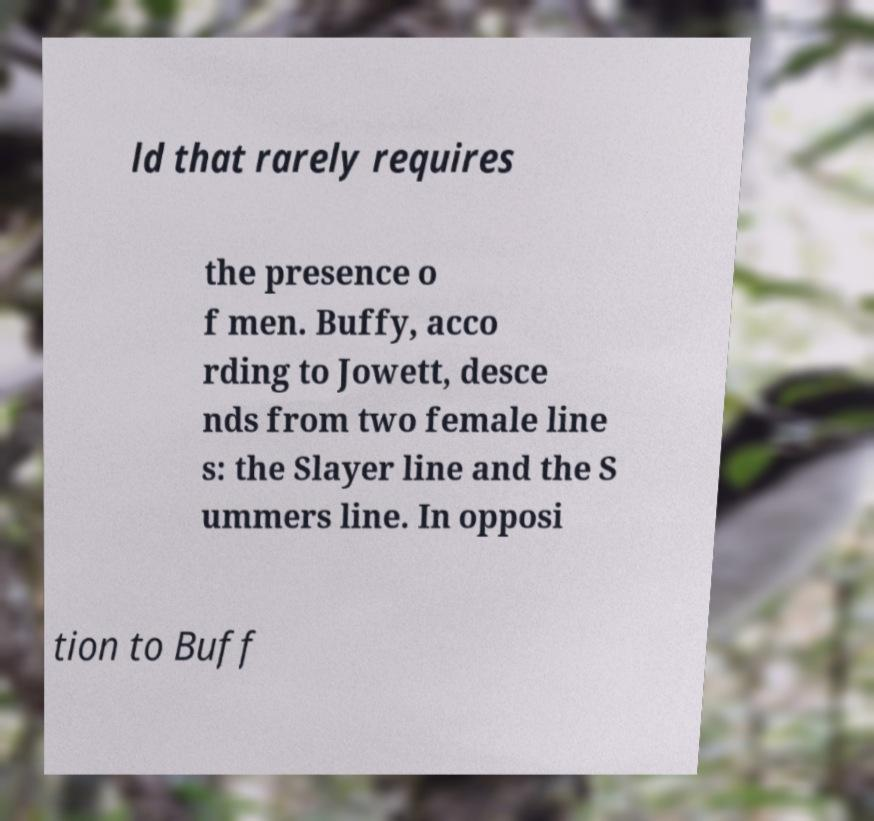Can you accurately transcribe the text from the provided image for me? ld that rarely requires the presence o f men. Buffy, acco rding to Jowett, desce nds from two female line s: the Slayer line and the S ummers line. In opposi tion to Buff 